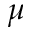<formula> <loc_0><loc_0><loc_500><loc_500>\mu</formula> 